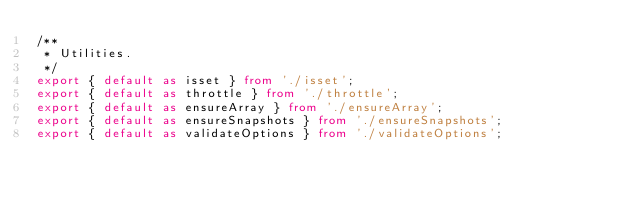<code> <loc_0><loc_0><loc_500><loc_500><_TypeScript_>/**
 * Utilities.
 */
export { default as isset } from './isset';
export { default as throttle } from './throttle';
export { default as ensureArray } from './ensureArray';
export { default as ensureSnapshots } from './ensureSnapshots';
export { default as validateOptions } from './validateOptions';
</code> 